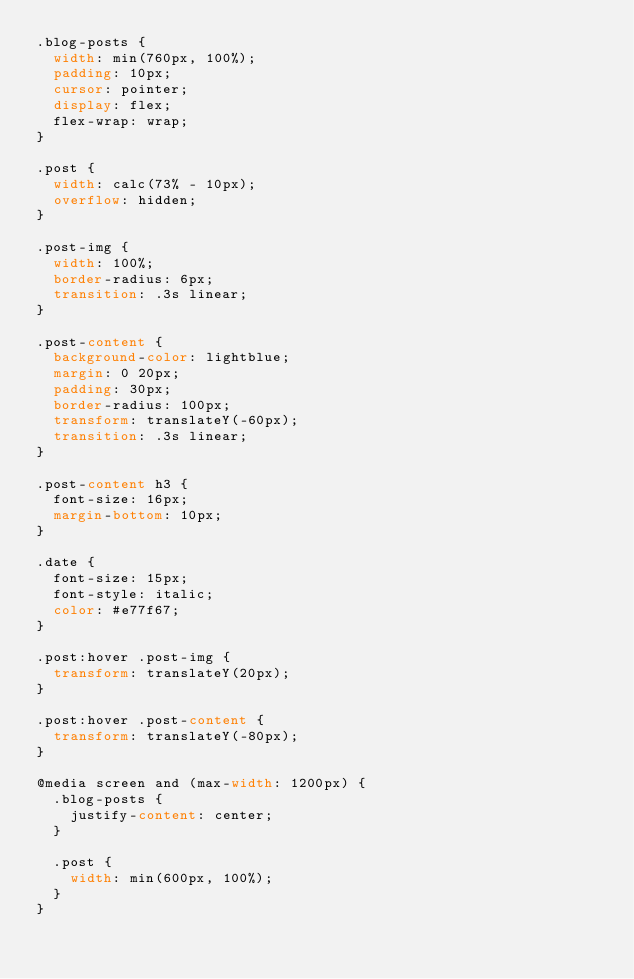<code> <loc_0><loc_0><loc_500><loc_500><_CSS_>.blog-posts {
  width: min(760px, 100%);
  padding: 10px;
  cursor: pointer;
  display: flex;
  flex-wrap: wrap;
}

.post {
  width: calc(73% - 10px);
  overflow: hidden;
}

.post-img {
  width: 100%;
  border-radius: 6px;
  transition: .3s linear;
}

.post-content {
  background-color: lightblue;
  margin: 0 20px;
  padding: 30px;
  border-radius: 100px;
  transform: translateY(-60px);
  transition: .3s linear;
}

.post-content h3 {
  font-size: 16px;
  margin-bottom: 10px;
}

.date {
  font-size: 15px;
  font-style: italic;
  color: #e77f67;
}

.post:hover .post-img {
  transform: translateY(20px);
}

.post:hover .post-content {
  transform: translateY(-80px);
}

@media screen and (max-width: 1200px) {
  .blog-posts {
    justify-content: center;
  }

  .post {
    width: min(600px, 100%);
  }
}</code> 